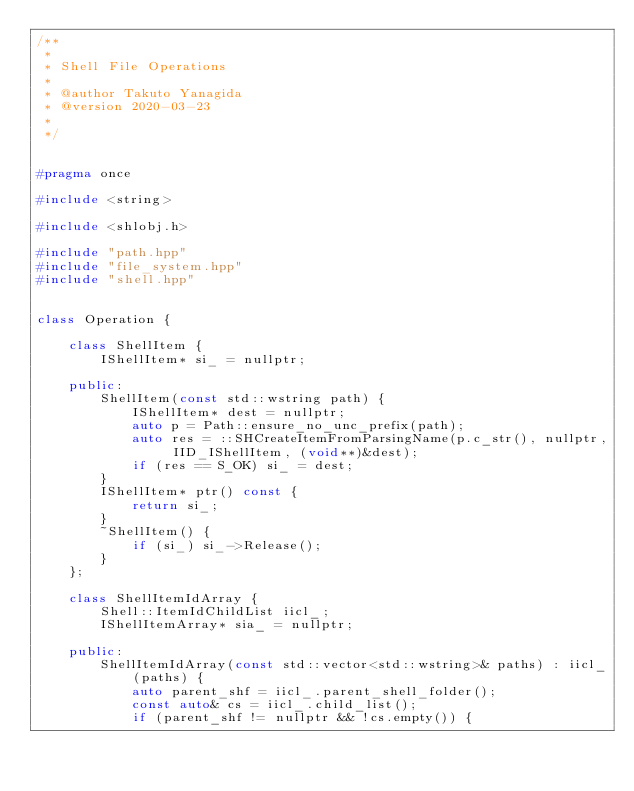Convert code to text. <code><loc_0><loc_0><loc_500><loc_500><_C++_>/**
 *
 * Shell File Operations
 *
 * @author Takuto Yanagida
 * @version 2020-03-23
 *
 */


#pragma once

#include <string>

#include <shlobj.h>

#include "path.hpp"
#include "file_system.hpp"
#include "shell.hpp"


class Operation {

	class ShellItem {
		IShellItem* si_ = nullptr;

	public:
		ShellItem(const std::wstring path) {
			IShellItem* dest = nullptr;
			auto p = Path::ensure_no_unc_prefix(path);
			auto res = ::SHCreateItemFromParsingName(p.c_str(), nullptr, IID_IShellItem, (void**)&dest);
			if (res == S_OK) si_ = dest;
		}
		IShellItem* ptr() const {
			return si_;
		}
		~ShellItem() {
			if (si_) si_->Release();
		}
	};

	class ShellItemIdArray {
		Shell::ItemIdChildList iicl_;
		IShellItemArray* sia_ = nullptr;

	public:
		ShellItemIdArray(const std::vector<std::wstring>& paths) : iicl_(paths) {
			auto parent_shf = iicl_.parent_shell_folder();
			const auto& cs = iicl_.child_list();
			if (parent_shf != nullptr && !cs.empty()) {</code> 